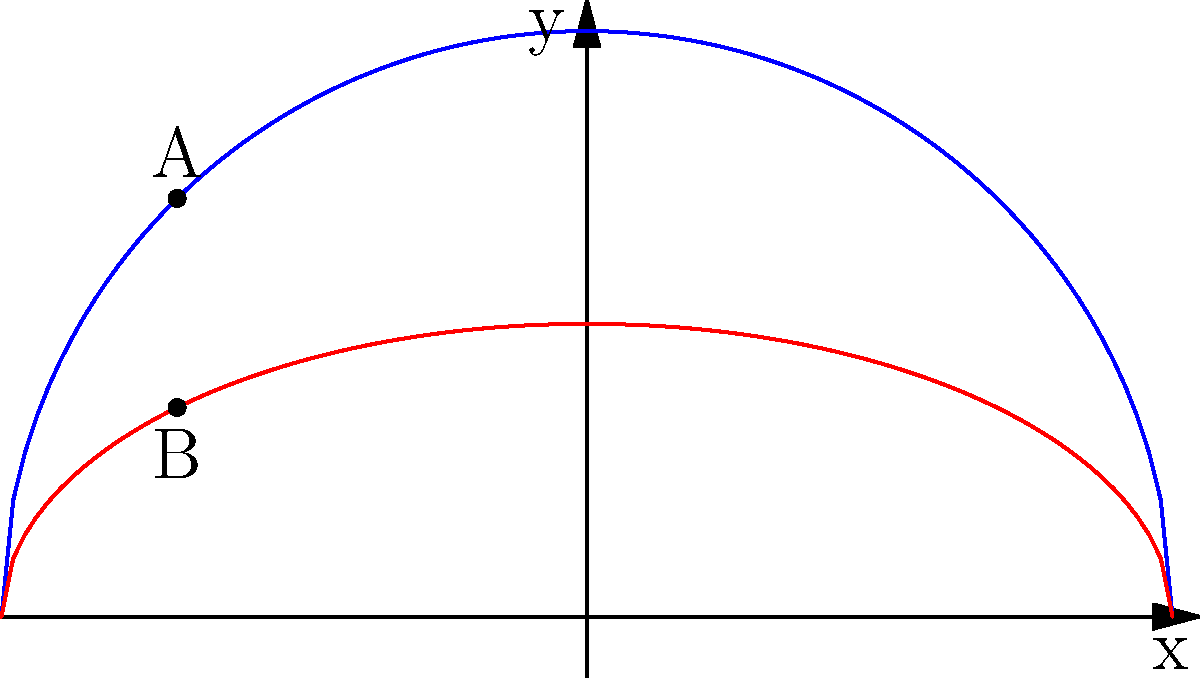In the context of railroad track design, engineers often need to optimize the curvature of tracks to minimize travel time. The graph shows two possible track designs between two points. Curve A (blue) represents a semicircle, while Curve B (red) represents a flatter curve. If a train travels at a constant speed proportional to the radius of curvature, which curve would result in a shorter travel time? Justify your answer using calculus concepts. To solve this problem, we'll use concepts from calculus, particularly arc length and the relationship between curvature and speed. Let's approach this step-by-step:

1) The radius of curvature for a semicircle (Curve A) is constant and equal to the radius of the circle. For Curve B, the radius of curvature varies but is generally larger than that of Curve A.

2) Given that the train's speed is proportional to the radius of curvature, the train will travel faster on Curve B than on Curve A at most points.

3) However, we also need to consider the total distance traveled. We can calculate this using the arc length formula:

   $$L = \int_{a}^{b} \sqrt{1 + (\frac{dy}{dx})^2} dx$$

4) For a semicircle (Curve A), this integral evaluates to $\pi r$, where $r$ is the radius.

5) For Curve B, the integral will result in a smaller value because the curve is flatter and thus shorter.

6) The travel time is given by:

   $$T = \int_{a}^{b} \frac{ds}{v(s)}$$

   where $s$ is the arc length and $v(s)$ is the speed at each point.

7) For Curve A, the speed is constant, so the integral simplifies to $T_A = \frac{\pi r}{v}$.

8) For Curve B, the speed varies but is generally higher, and the total distance is shorter. This will result in a smaller value for the integral.

Therefore, despite the varying speed, Curve B will result in a shorter travel time due to its shorter length and generally higher speed.
Answer: Curve B (flatter curve) results in shorter travel time. 